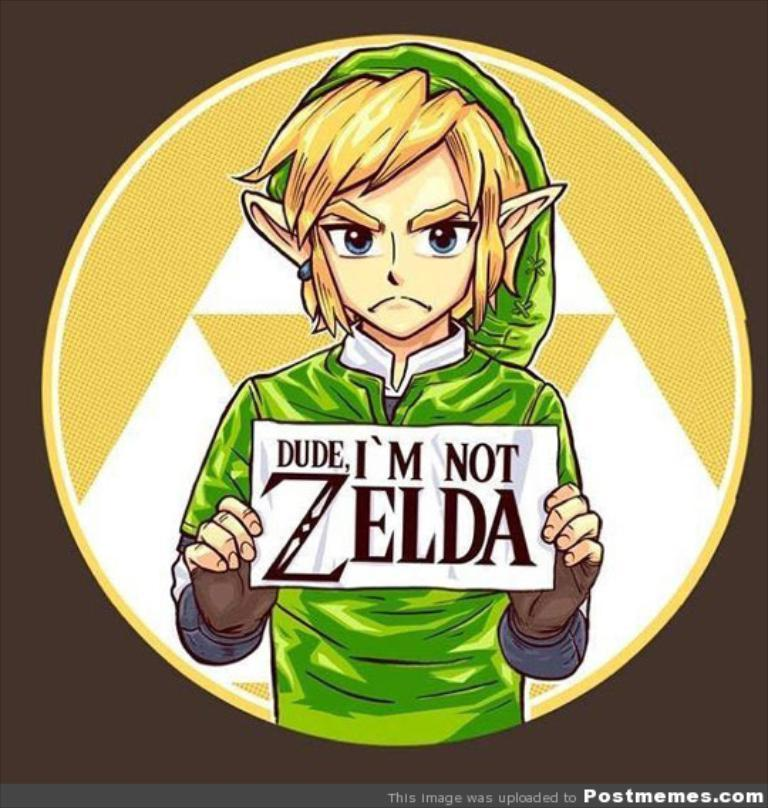<image>
Relay a brief, clear account of the picture shown. a character holding an I'm not Zelda sign 